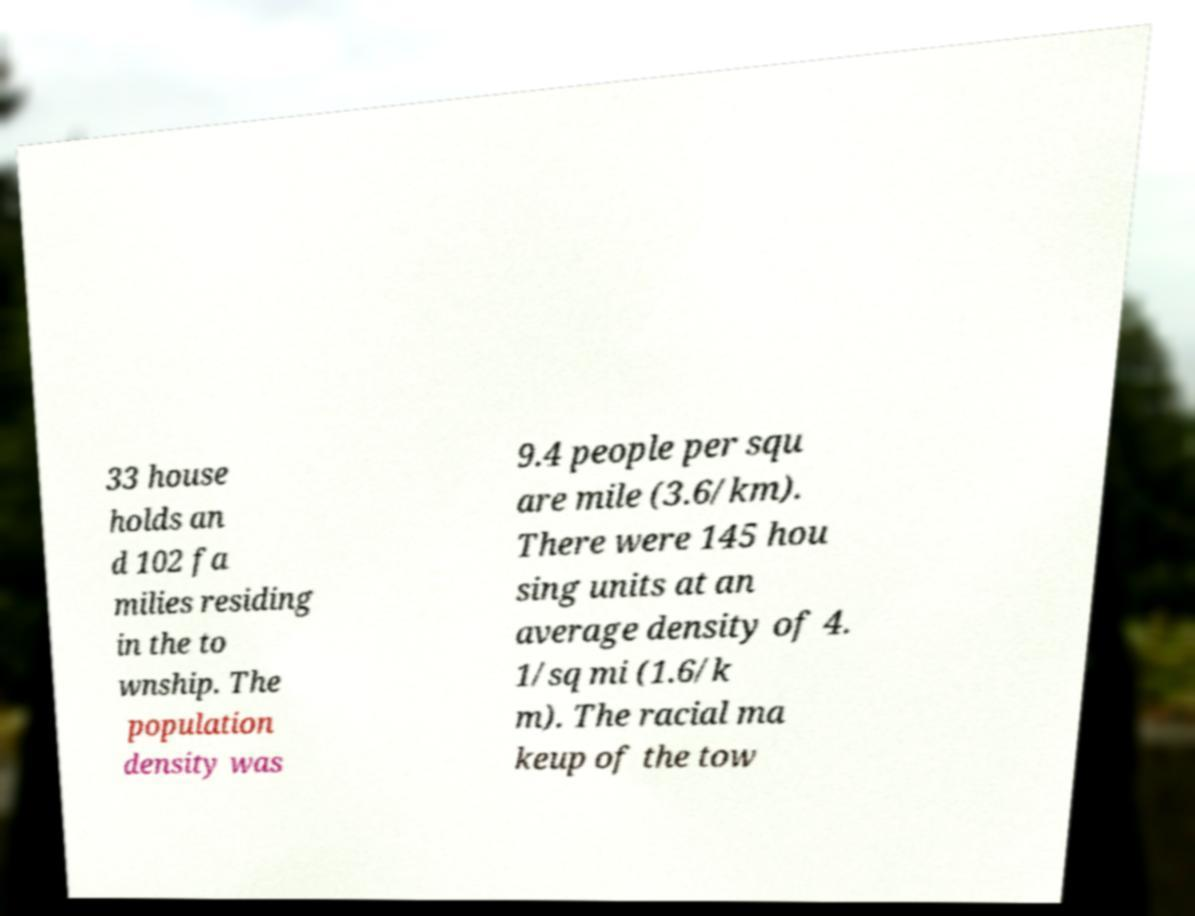What messages or text are displayed in this image? I need them in a readable, typed format. 33 house holds an d 102 fa milies residing in the to wnship. The population density was 9.4 people per squ are mile (3.6/km). There were 145 hou sing units at an average density of 4. 1/sq mi (1.6/k m). The racial ma keup of the tow 